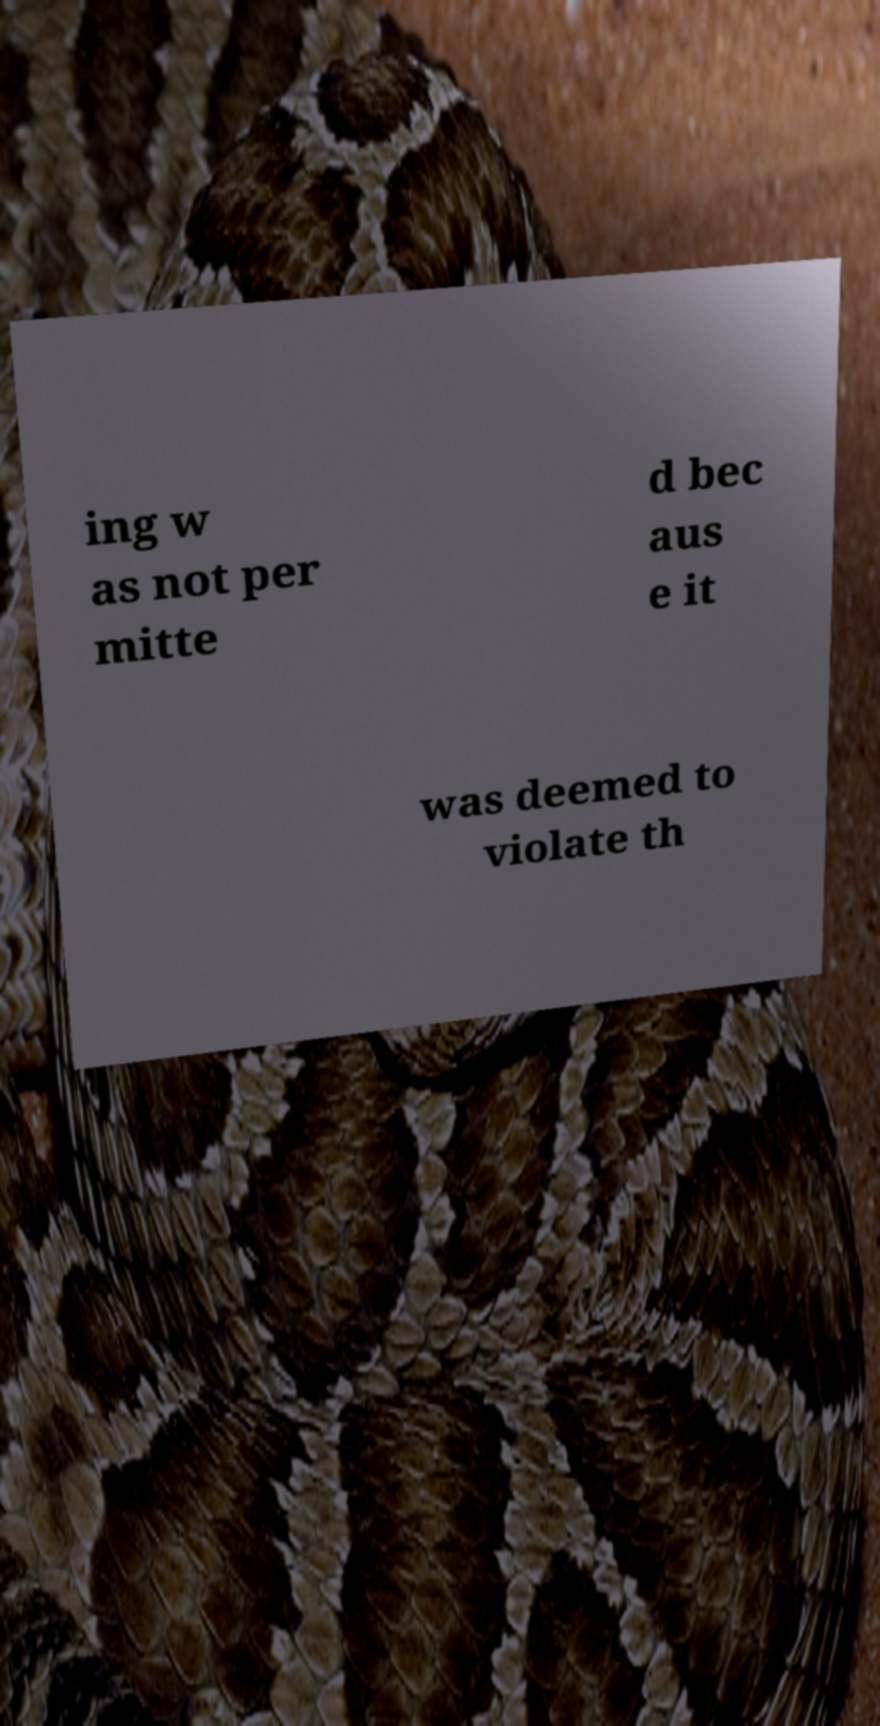Can you accurately transcribe the text from the provided image for me? ing w as not per mitte d bec aus e it was deemed to violate th 